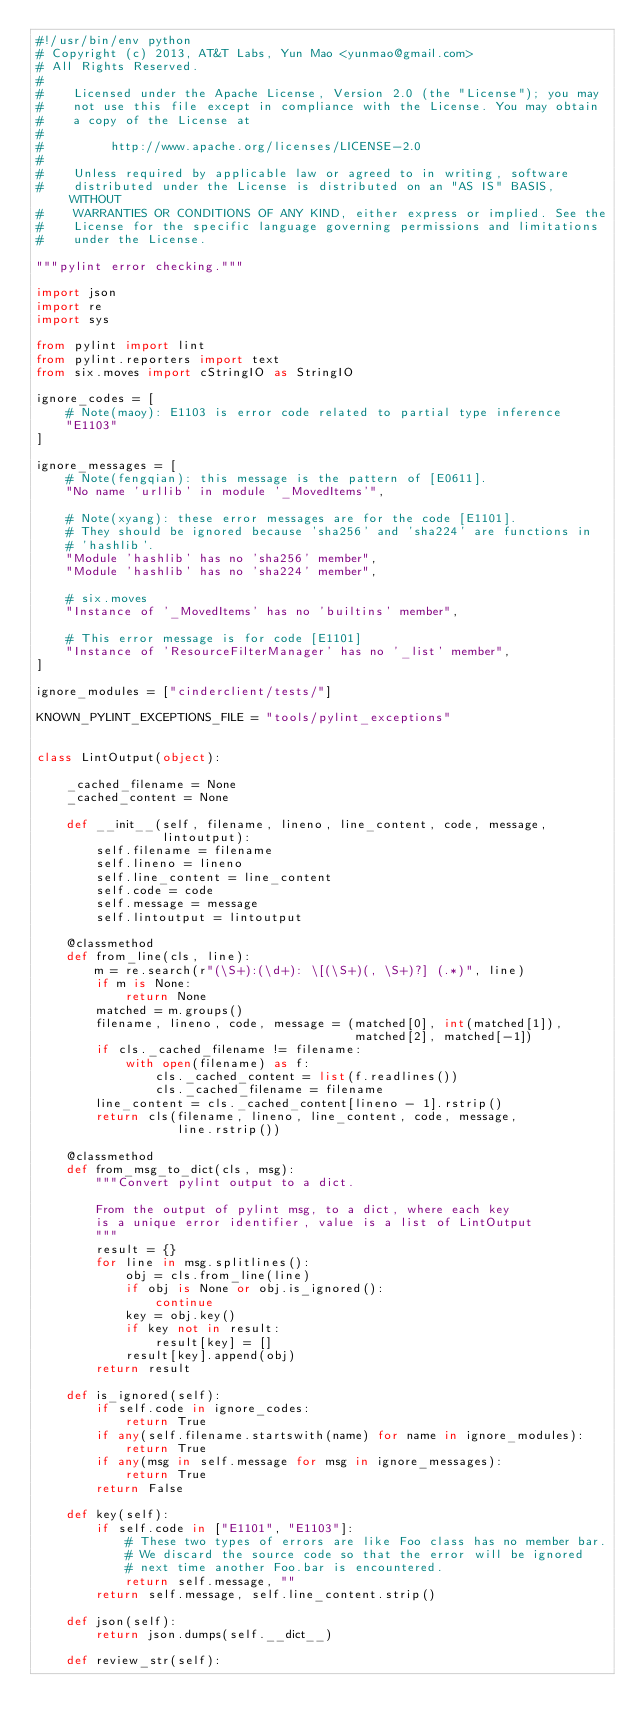Convert code to text. <code><loc_0><loc_0><loc_500><loc_500><_Python_>#!/usr/bin/env python
# Copyright (c) 2013, AT&T Labs, Yun Mao <yunmao@gmail.com>
# All Rights Reserved.
#
#    Licensed under the Apache License, Version 2.0 (the "License"); you may
#    not use this file except in compliance with the License. You may obtain
#    a copy of the License at
#
#         http://www.apache.org/licenses/LICENSE-2.0
#
#    Unless required by applicable law or agreed to in writing, software
#    distributed under the License is distributed on an "AS IS" BASIS, WITHOUT
#    WARRANTIES OR CONDITIONS OF ANY KIND, either express or implied. See the
#    License for the specific language governing permissions and limitations
#    under the License.

"""pylint error checking."""

import json
import re
import sys

from pylint import lint
from pylint.reporters import text
from six.moves import cStringIO as StringIO

ignore_codes = [
    # Note(maoy): E1103 is error code related to partial type inference
    "E1103"
]

ignore_messages = [
    # Note(fengqian): this message is the pattern of [E0611].
    "No name 'urllib' in module '_MovedItems'",

    # Note(xyang): these error messages are for the code [E1101].
    # They should be ignored because 'sha256' and 'sha224' are functions in
    # 'hashlib'.
    "Module 'hashlib' has no 'sha256' member",
    "Module 'hashlib' has no 'sha224' member",

    # six.moves
    "Instance of '_MovedItems' has no 'builtins' member",

    # This error message is for code [E1101]
    "Instance of 'ResourceFilterManager' has no '_list' member",
]

ignore_modules = ["cinderclient/tests/"]

KNOWN_PYLINT_EXCEPTIONS_FILE = "tools/pylint_exceptions"


class LintOutput(object):

    _cached_filename = None
    _cached_content = None

    def __init__(self, filename, lineno, line_content, code, message,
                 lintoutput):
        self.filename = filename
        self.lineno = lineno
        self.line_content = line_content
        self.code = code
        self.message = message
        self.lintoutput = lintoutput

    @classmethod
    def from_line(cls, line):
        m = re.search(r"(\S+):(\d+): \[(\S+)(, \S+)?] (.*)", line)
        if m is None:
            return None
        matched = m.groups()
        filename, lineno, code, message = (matched[0], int(matched[1]),
                                           matched[2], matched[-1])
        if cls._cached_filename != filename:
            with open(filename) as f:
                cls._cached_content = list(f.readlines())
                cls._cached_filename = filename
        line_content = cls._cached_content[lineno - 1].rstrip()
        return cls(filename, lineno, line_content, code, message,
                   line.rstrip())

    @classmethod
    def from_msg_to_dict(cls, msg):
        """Convert pylint output to a dict.

        From the output of pylint msg, to a dict, where each key
        is a unique error identifier, value is a list of LintOutput
        """
        result = {}
        for line in msg.splitlines():
            obj = cls.from_line(line)
            if obj is None or obj.is_ignored():
                continue
            key = obj.key()
            if key not in result:
                result[key] = []
            result[key].append(obj)
        return result

    def is_ignored(self):
        if self.code in ignore_codes:
            return True
        if any(self.filename.startswith(name) for name in ignore_modules):
            return True
        if any(msg in self.message for msg in ignore_messages):
            return True
        return False

    def key(self):
        if self.code in ["E1101", "E1103"]:
            # These two types of errors are like Foo class has no member bar.
            # We discard the source code so that the error will be ignored
            # next time another Foo.bar is encountered.
            return self.message, ""
        return self.message, self.line_content.strip()

    def json(self):
        return json.dumps(self.__dict__)

    def review_str(self):</code> 